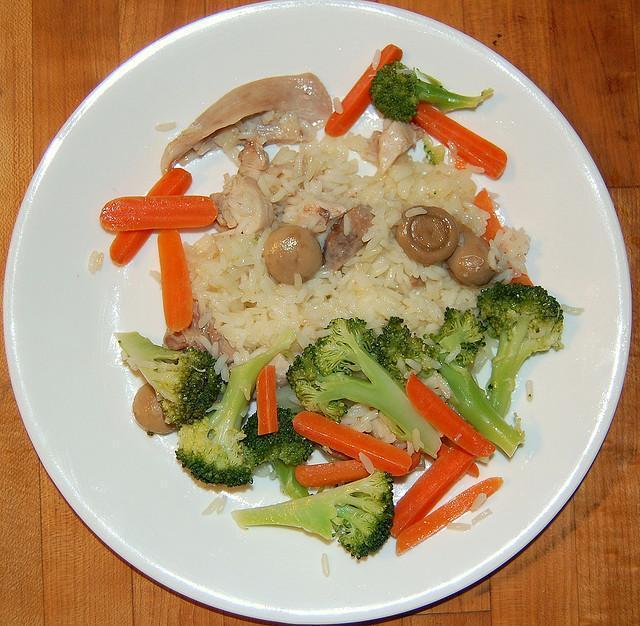How many broccolis are there?
Give a very brief answer. 7. How many carrots are there?
Give a very brief answer. 8. 